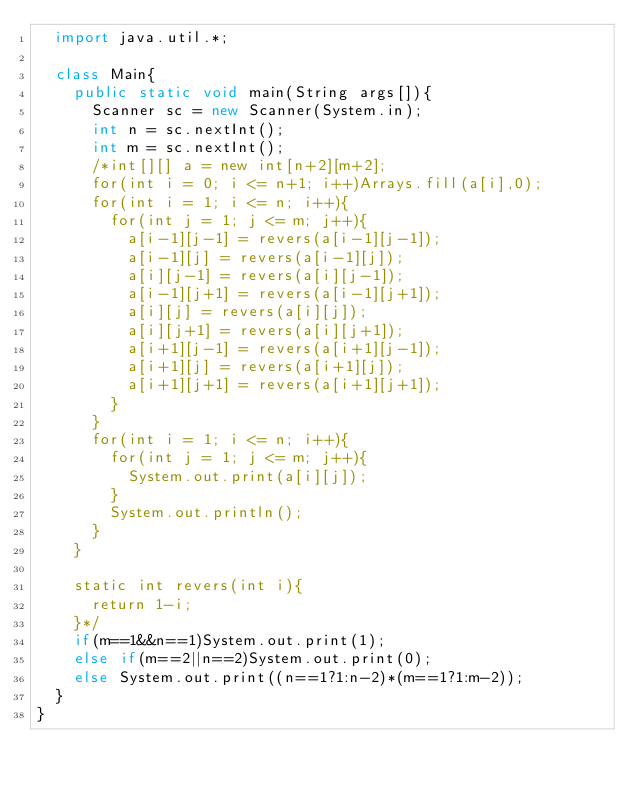<code> <loc_0><loc_0><loc_500><loc_500><_Java_>  import java.util.*;

  class Main{
    public static void main(String args[]){
      Scanner sc = new Scanner(System.in);
      int n = sc.nextInt();
      int m = sc.nextInt();
      /*int[][] a = new int[n+2][m+2];
      for(int i = 0; i <= n+1; i++)Arrays.fill(a[i],0);
      for(int i = 1; i <= n; i++){
        for(int j = 1; j <= m; j++){
          a[i-1][j-1] = revers(a[i-1][j-1]);
          a[i-1][j] = revers(a[i-1][j]);
          a[i][j-1] = revers(a[i][j-1]);
          a[i-1][j+1] = revers(a[i-1][j+1]);
          a[i][j] = revers(a[i][j]);
          a[i][j+1] = revers(a[i][j+1]);
          a[i+1][j-1] = revers(a[i+1][j-1]);
          a[i+1][j] = revers(a[i+1][j]);
          a[i+1][j+1] = revers(a[i+1][j+1]);
        }
      }
      for(int i = 1; i <= n; i++){
        for(int j = 1; j <= m; j++){
          System.out.print(a[i][j]);
        }
        System.out.println();
      }
    }

    static int revers(int i){
      return 1-i;
    }*/
    if(m==1&&n==1)System.out.print(1);
    else if(m==2||n==2)System.out.print(0);
    else System.out.print((n==1?1:n-2)*(m==1?1:m-2));
  }
}
</code> 